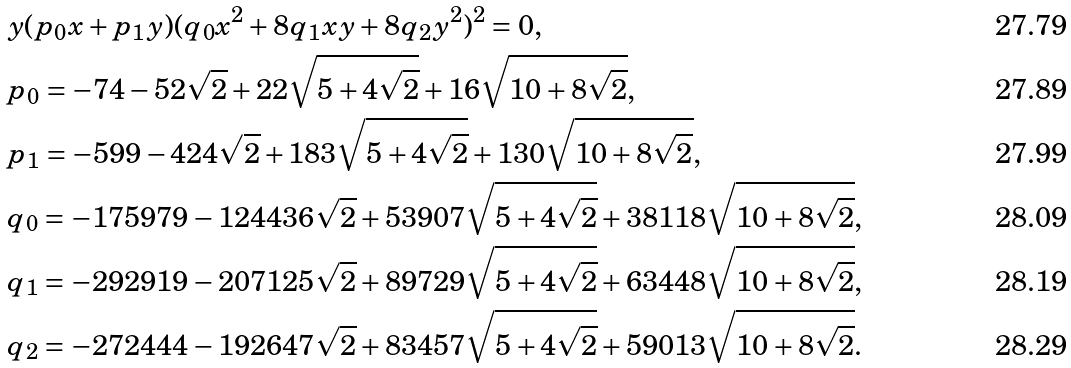Convert formula to latex. <formula><loc_0><loc_0><loc_500><loc_500>& y ( p _ { 0 } x + p _ { 1 } y ) ( q _ { 0 } x ^ { 2 } + 8 q _ { 1 } x y + 8 q _ { 2 } y ^ { 2 } ) ^ { 2 } = 0 , \\ & p _ { 0 } = - 7 4 - 5 2 \sqrt { 2 } + 2 2 \sqrt { 5 + 4 \sqrt { 2 } } + 1 6 \sqrt { 1 0 + 8 \sqrt { 2 } } , \\ & p _ { 1 } = - 5 9 9 - 4 2 4 \sqrt { 2 } + 1 8 3 \sqrt { 5 + 4 \sqrt { 2 } } + 1 3 0 \sqrt { 1 0 + 8 \sqrt { 2 } } , \\ & q _ { 0 } = - 1 7 5 9 7 9 - 1 2 4 4 3 6 \sqrt { 2 } + 5 3 9 0 7 \sqrt { 5 + 4 \sqrt { 2 } } + 3 8 1 1 8 \sqrt { 1 0 + 8 \sqrt { 2 } } , \\ & q _ { 1 } = - 2 9 2 9 1 9 - 2 0 7 1 2 5 \sqrt { 2 } + 8 9 7 2 9 \sqrt { 5 + 4 \sqrt { 2 } } + 6 3 4 4 8 \sqrt { 1 0 + 8 \sqrt { 2 } } , \\ & q _ { 2 } = - 2 7 2 4 4 4 - 1 9 2 6 4 7 \sqrt { 2 } + 8 3 4 5 7 \sqrt { 5 + 4 \sqrt { 2 } } + 5 9 0 1 3 \sqrt { 1 0 + 8 \sqrt { 2 } } .</formula> 